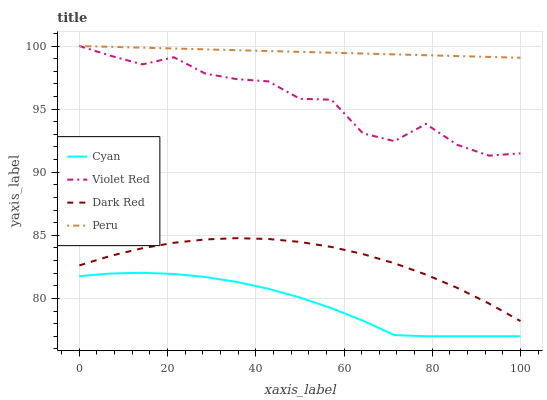Does Cyan have the minimum area under the curve?
Answer yes or no. Yes. Does Peru have the maximum area under the curve?
Answer yes or no. Yes. Does Violet Red have the minimum area under the curve?
Answer yes or no. No. Does Violet Red have the maximum area under the curve?
Answer yes or no. No. Is Peru the smoothest?
Answer yes or no. Yes. Is Violet Red the roughest?
Answer yes or no. Yes. Is Violet Red the smoothest?
Answer yes or no. No. Is Peru the roughest?
Answer yes or no. No. Does Cyan have the lowest value?
Answer yes or no. Yes. Does Violet Red have the lowest value?
Answer yes or no. No. Does Peru have the highest value?
Answer yes or no. Yes. Does Dark Red have the highest value?
Answer yes or no. No. Is Dark Red less than Violet Red?
Answer yes or no. Yes. Is Dark Red greater than Cyan?
Answer yes or no. Yes. Does Violet Red intersect Peru?
Answer yes or no. Yes. Is Violet Red less than Peru?
Answer yes or no. No. Is Violet Red greater than Peru?
Answer yes or no. No. Does Dark Red intersect Violet Red?
Answer yes or no. No. 